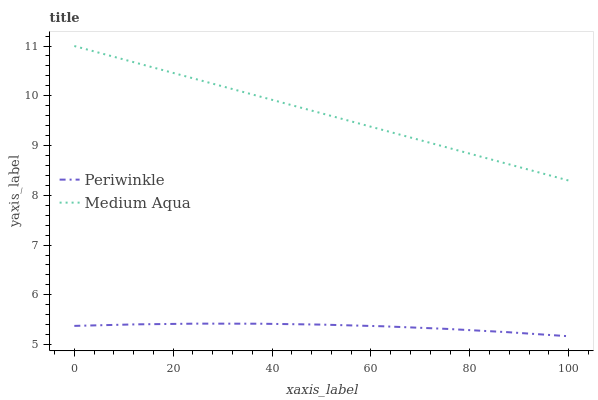Does Periwinkle have the minimum area under the curve?
Answer yes or no. Yes. Does Medium Aqua have the maximum area under the curve?
Answer yes or no. Yes. Does Periwinkle have the maximum area under the curve?
Answer yes or no. No. Is Medium Aqua the smoothest?
Answer yes or no. Yes. Is Periwinkle the roughest?
Answer yes or no. Yes. Is Periwinkle the smoothest?
Answer yes or no. No. Does Periwinkle have the lowest value?
Answer yes or no. Yes. Does Medium Aqua have the highest value?
Answer yes or no. Yes. Does Periwinkle have the highest value?
Answer yes or no. No. Is Periwinkle less than Medium Aqua?
Answer yes or no. Yes. Is Medium Aqua greater than Periwinkle?
Answer yes or no. Yes. Does Periwinkle intersect Medium Aqua?
Answer yes or no. No. 